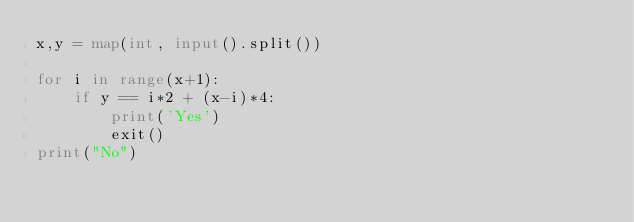<code> <loc_0><loc_0><loc_500><loc_500><_Python_>x,y = map(int, input().split())

for i in range(x+1):
    if y == i*2 + (x-i)*4:
        print('Yes')
        exit()
print("No")</code> 